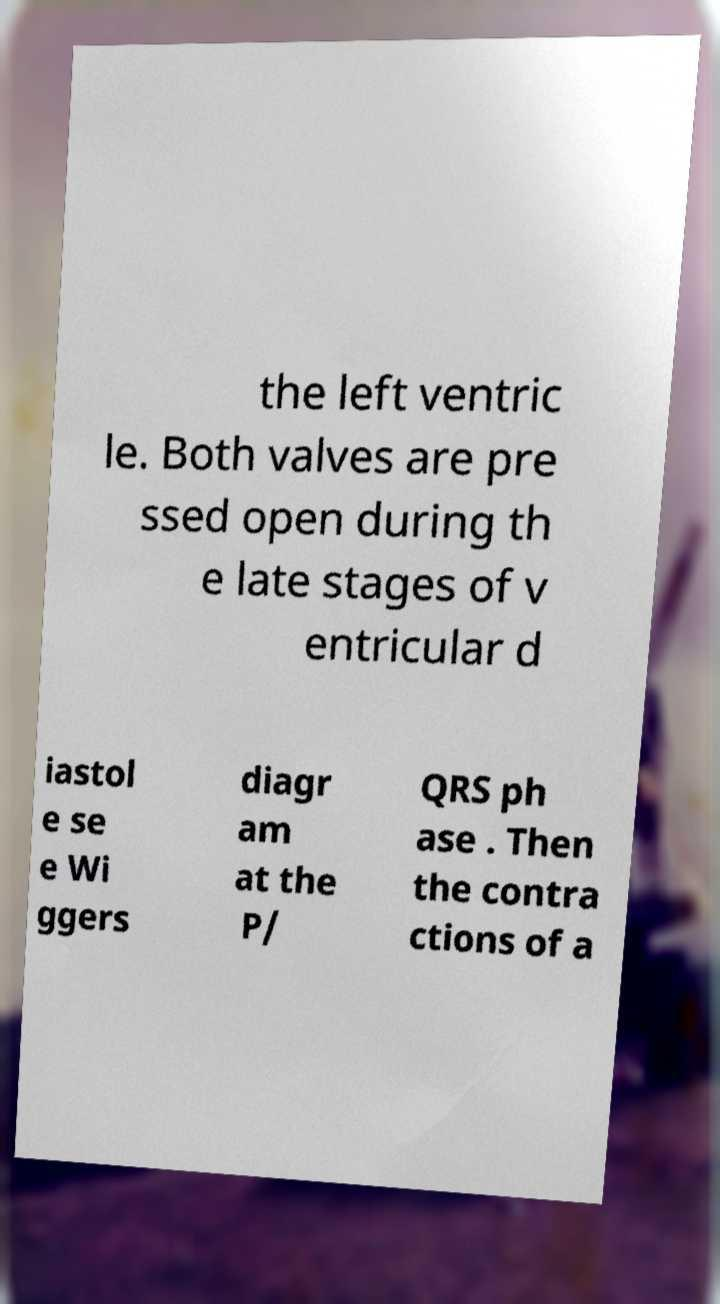I need the written content from this picture converted into text. Can you do that? the left ventric le. Both valves are pre ssed open during th e late stages of v entricular d iastol e se e Wi ggers diagr am at the P/ QRS ph ase . Then the contra ctions of a 